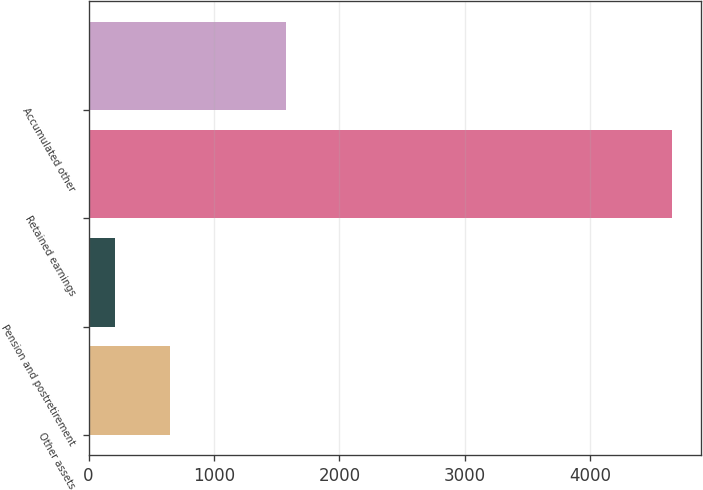Convert chart to OTSL. <chart><loc_0><loc_0><loc_500><loc_500><bar_chart><fcel>Other assets<fcel>Pension and postretirement<fcel>Retained earnings<fcel>Accumulated other<nl><fcel>653.64<fcel>209.1<fcel>4654.5<fcel>1573.9<nl></chart> 